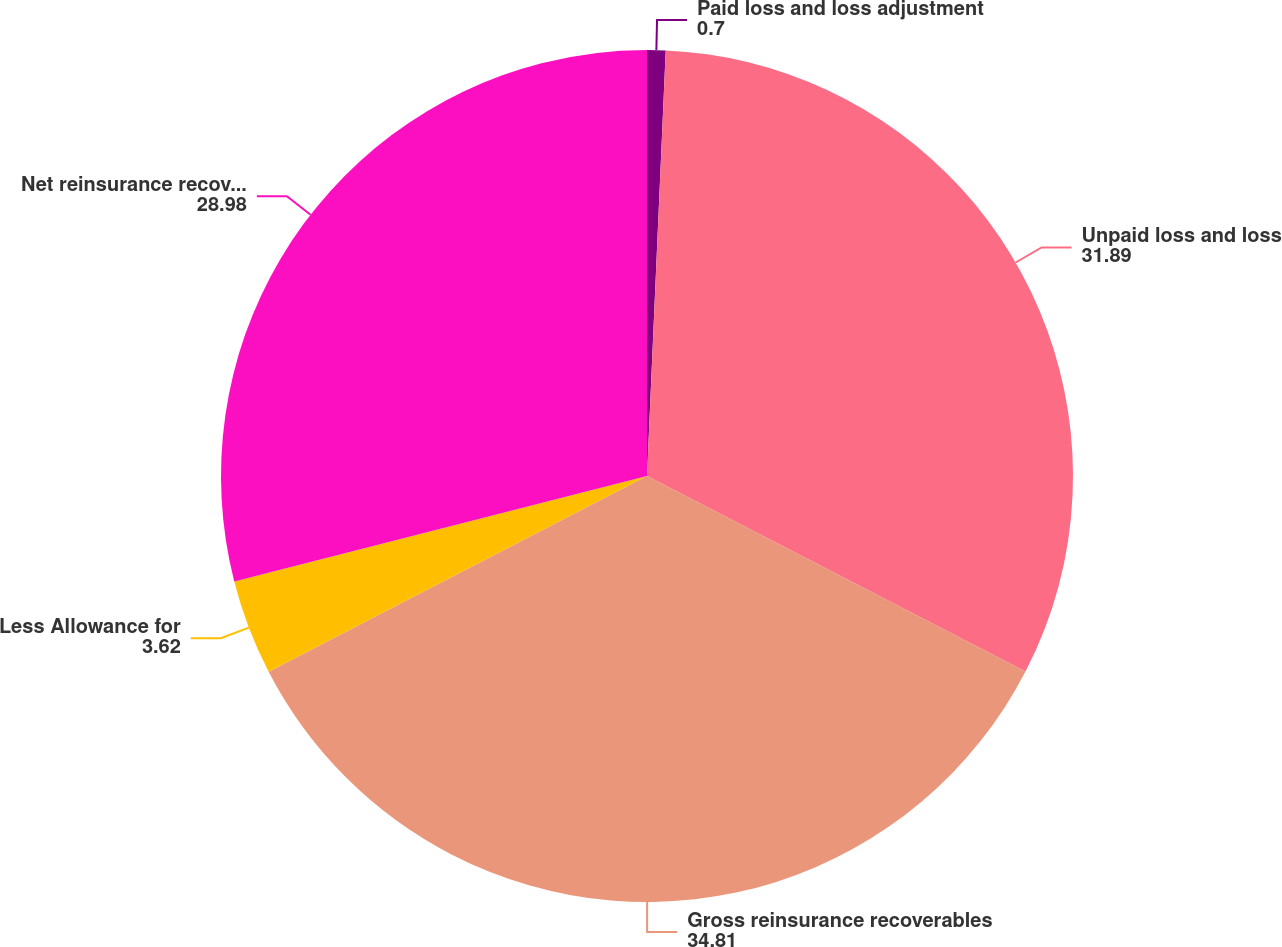<chart> <loc_0><loc_0><loc_500><loc_500><pie_chart><fcel>Paid loss and loss adjustment<fcel>Unpaid loss and loss<fcel>Gross reinsurance recoverables<fcel>Less Allowance for<fcel>Net reinsurance recoverables 1<nl><fcel>0.7%<fcel>31.89%<fcel>34.81%<fcel>3.62%<fcel>28.98%<nl></chart> 